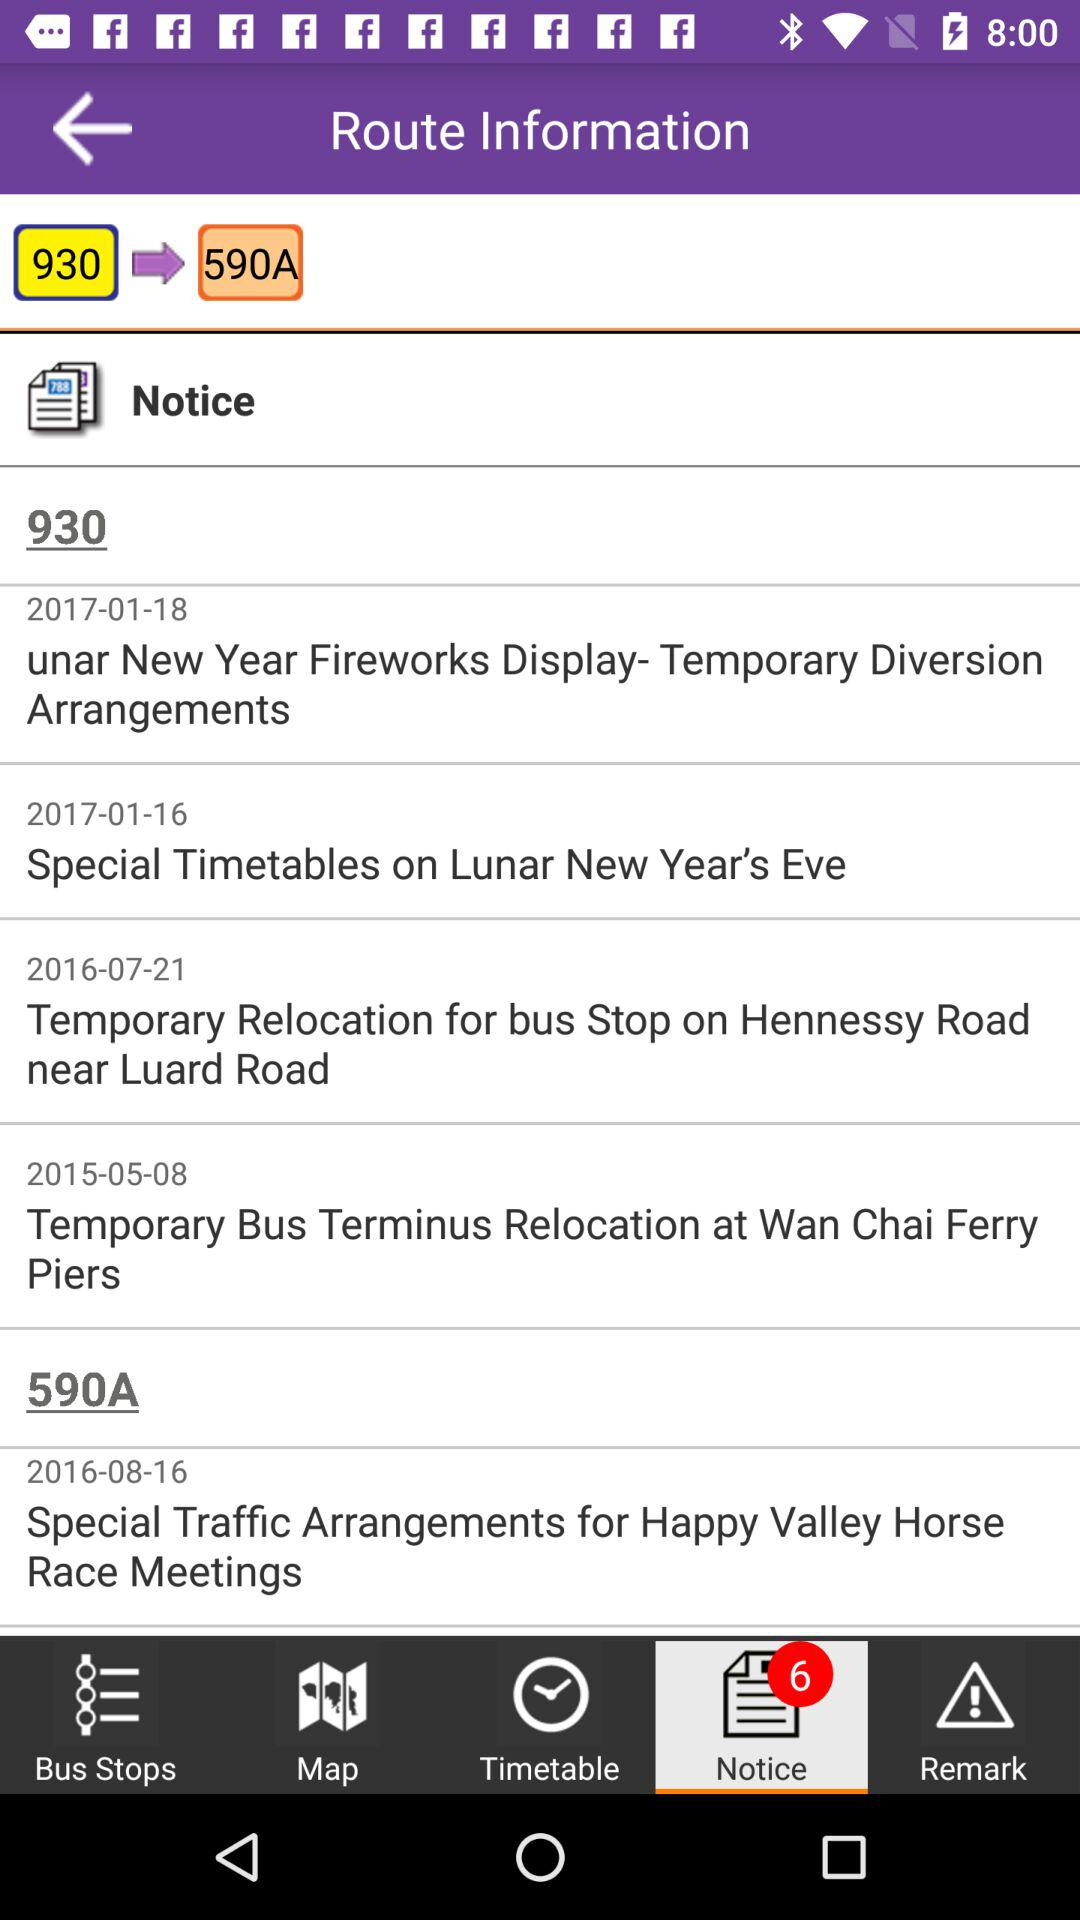What was the notice for the route on 2017-01-18? The notice for the route on January 18, 2017 was "unar New Year Fireworks Display- Temporary Diversion Arrangements". 